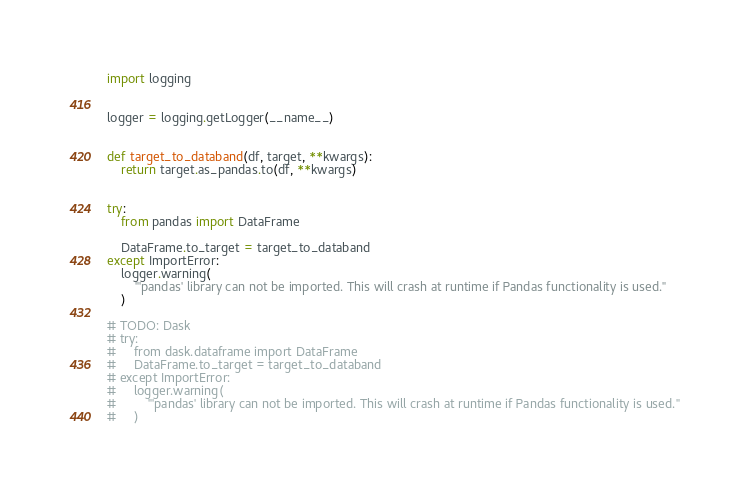Convert code to text. <code><loc_0><loc_0><loc_500><loc_500><_Python_>import logging


logger = logging.getLogger(__name__)


def target_to_databand(df, target, **kwargs):
    return target.as_pandas.to(df, **kwargs)


try:
    from pandas import DataFrame

    DataFrame.to_target = target_to_databand
except ImportError:
    logger.warning(
        "'pandas' library can not be imported. This will crash at runtime if Pandas functionality is used."
    )

# TODO: Dask
# try:
#     from dask.dataframe import DataFrame
#     DataFrame.to_target = target_to_databand
# except ImportError:
#     logger.warning(
#         "'pandas' library can not be imported. This will crash at runtime if Pandas functionality is used."
#     )
</code> 